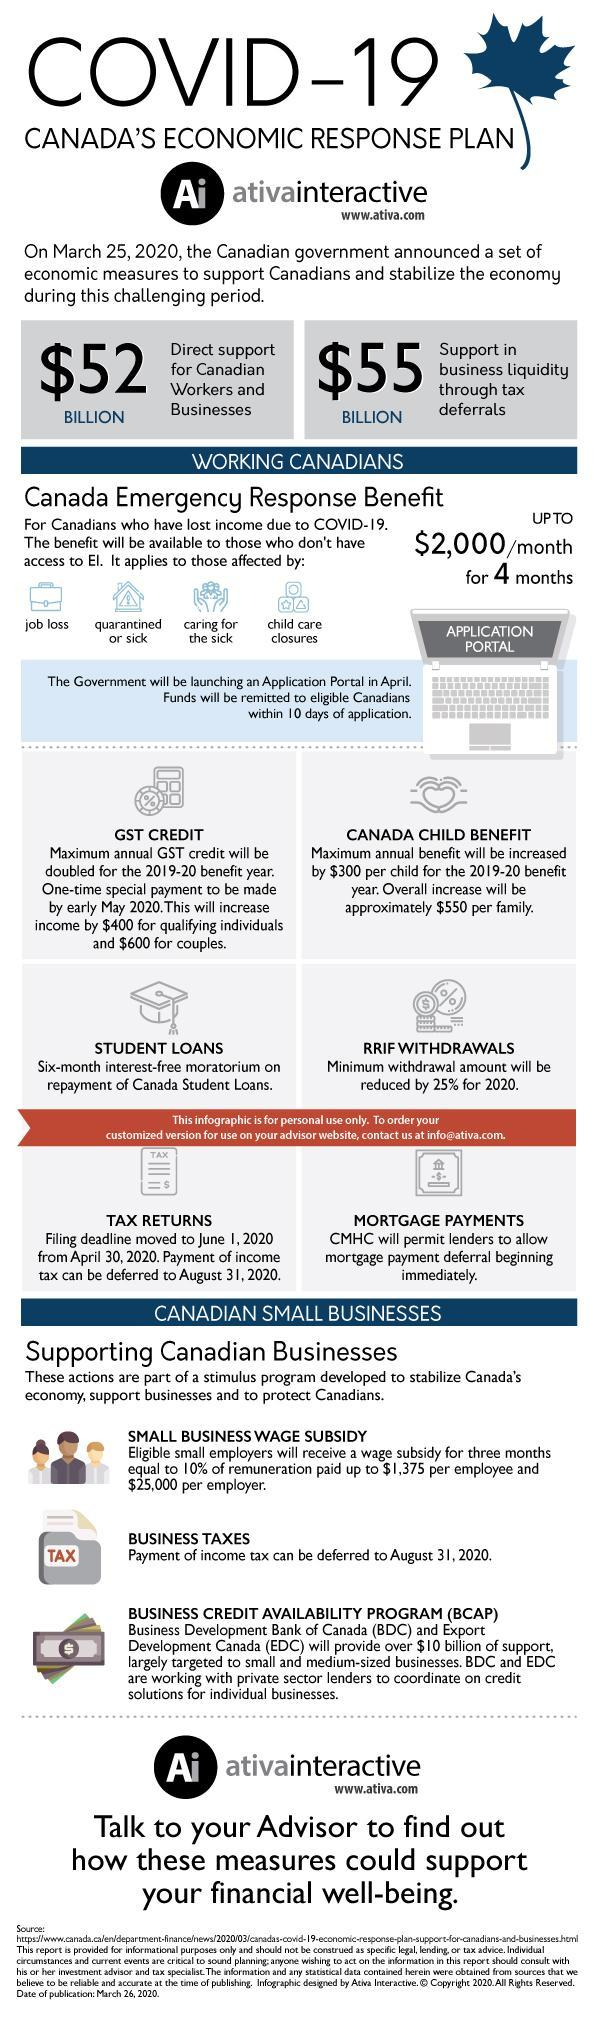What is written on the laptop?
Answer the question with a short phrase. Application Portal Which symbol is on the money? $ Job loss represented using which symbol-bag, or money? bag 